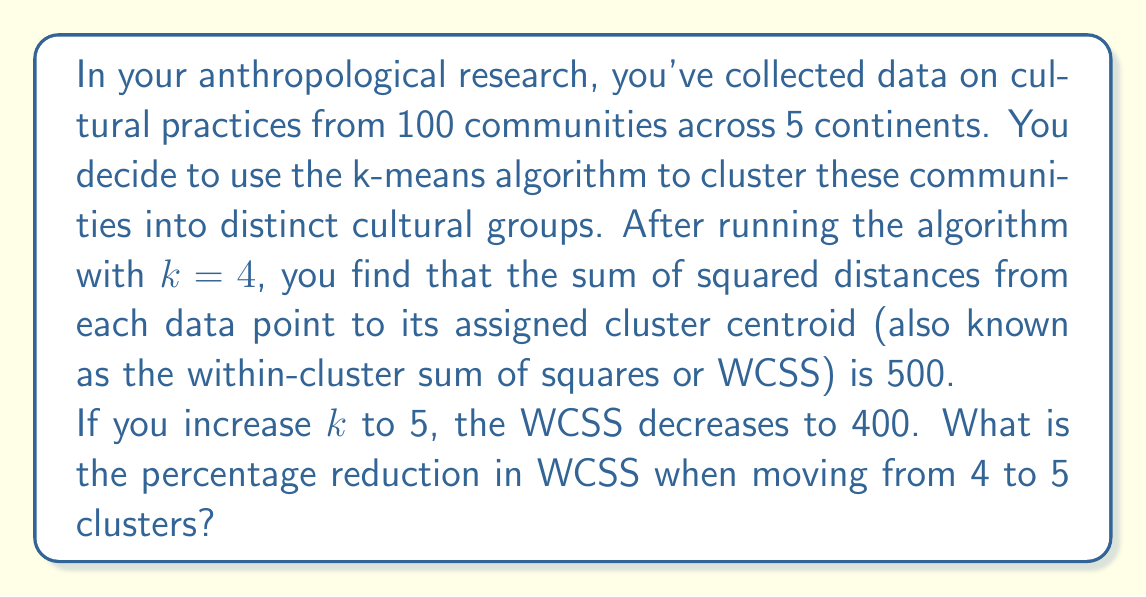Teach me how to tackle this problem. To solve this problem, we need to calculate the percentage reduction in the Within-Cluster Sum of Squares (WCSS) when increasing the number of clusters from 4 to 5. Let's break it down step-by-step:

1. Given information:
   - WCSS for k=4: 500
   - WCSS for k=5: 400

2. Calculate the difference in WCSS:
   $$\text{Difference} = \text{WCSS}_{k=4} - \text{WCSS}_{k=5} = 500 - 400 = 100$$

3. Calculate the percentage reduction:
   $$\text{Percentage Reduction} = \frac{\text{Difference}}{\text{WCSS}_{k=4}} \times 100\%$$

4. Substitute the values:
   $$\text{Percentage Reduction} = \frac{100}{500} \times 100\% = 0.2 \times 100\% = 20\%$$

The percentage reduction in WCSS when moving from 4 to 5 clusters is 20%.

This reduction indicates that adding a fifth cluster has improved the model's fit to the data, as the data points are now closer to their respective cluster centroids. In the context of anthropological research, this suggests that using 5 clusters might provide a more nuanced categorization of cultural groups compared to 4 clusters.
Answer: 20% 